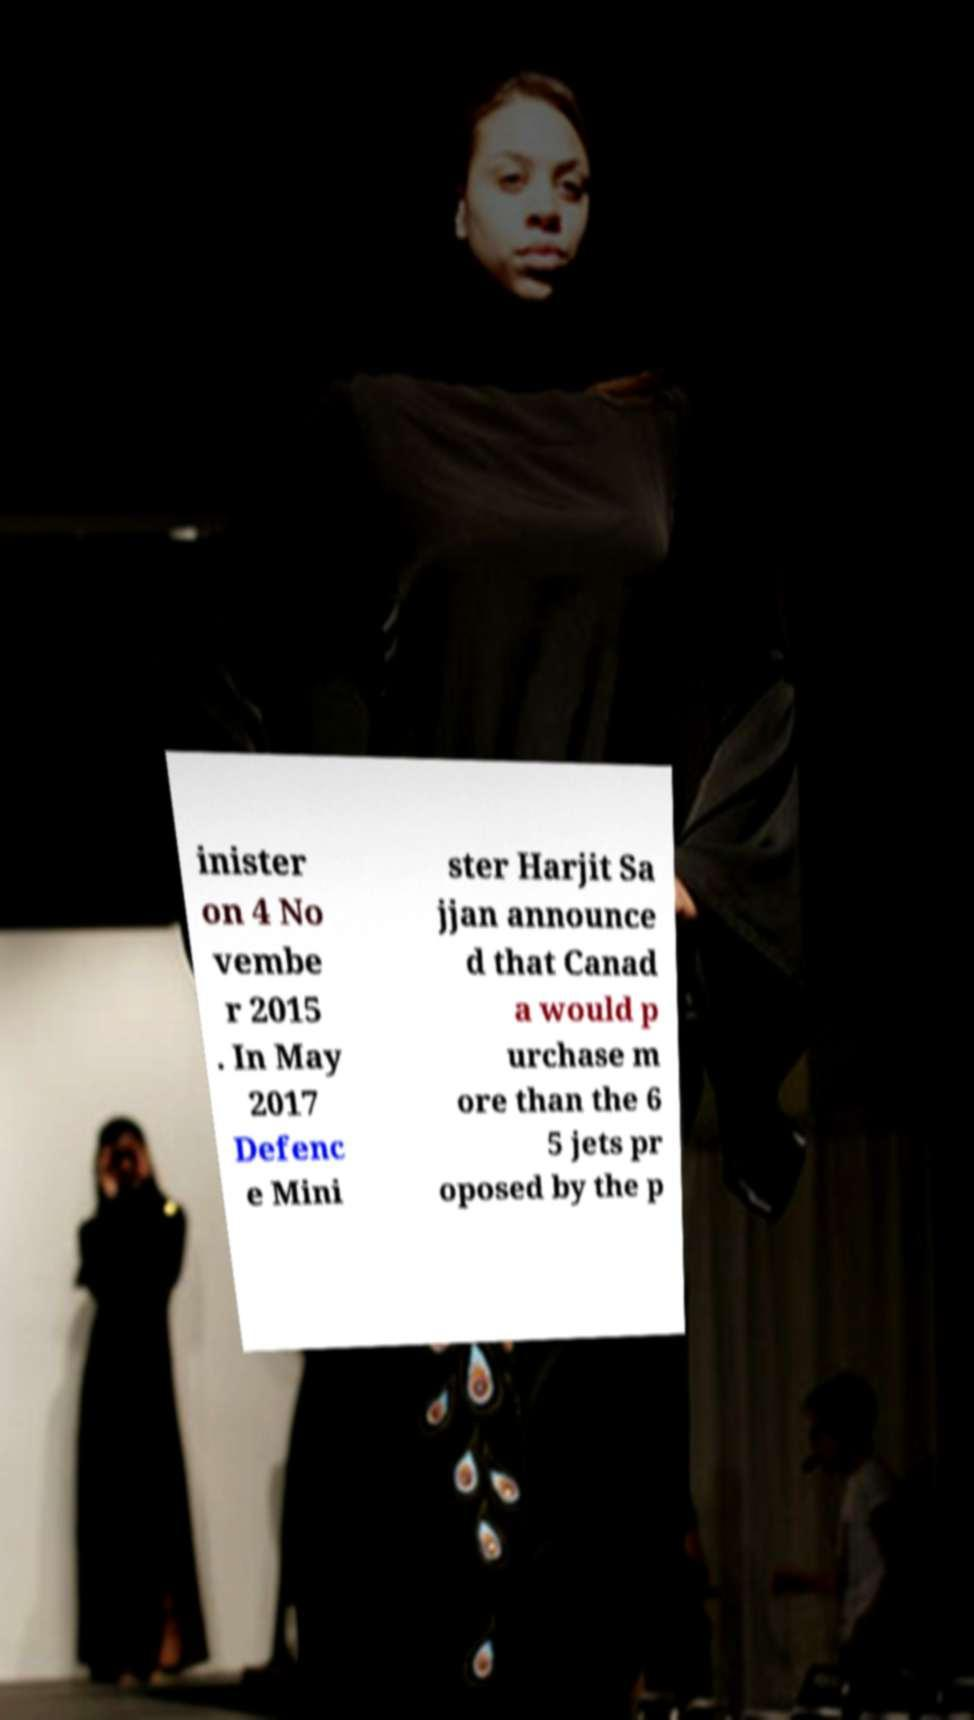For documentation purposes, I need the text within this image transcribed. Could you provide that? inister on 4 No vembe r 2015 . In May 2017 Defenc e Mini ster Harjit Sa jjan announce d that Canad a would p urchase m ore than the 6 5 jets pr oposed by the p 